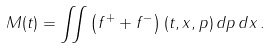Convert formula to latex. <formula><loc_0><loc_0><loc_500><loc_500>M ( t ) = \iint \left ( f ^ { + } + f ^ { - } \right ) ( t , x , p ) \, d p \, d x \, .</formula> 